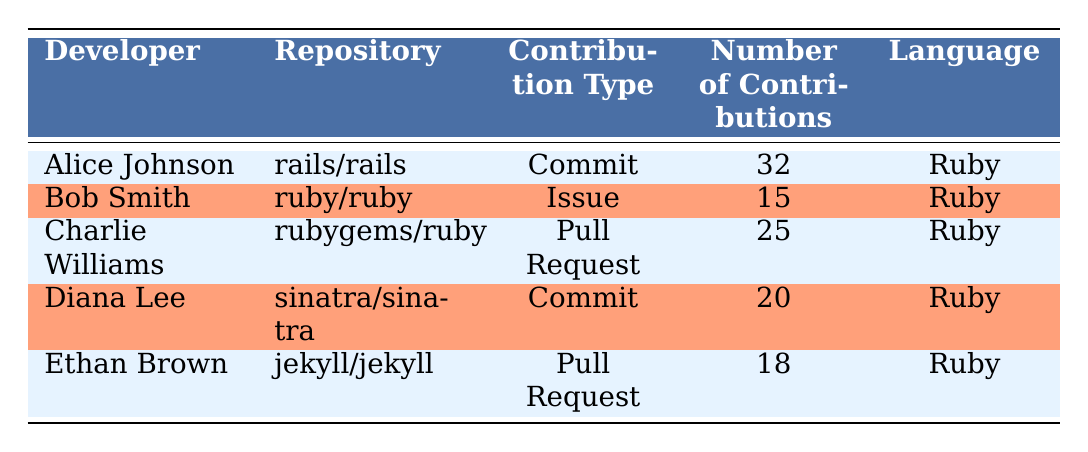What is the total number of contributions made by Alice Johnson? Alice Johnson made 32 contributions according to the table, which can be found in the "Number of Contributions" column corresponding to her name.
Answer: 32 Which developer contributed the most to the repository? Alice Johnson contributed the most with 32 contributions, which is the highest number listed in the "Number of Contributions" column.
Answer: Alice Johnson Is there a developer who only contributed by creating issues? Yes, Bob Smith is the only developer who contributed by creating issues, as indicated by his contribution type in the table.
Answer: Yes What is the average number of contributions from all developers listed? To find the average, first sum up the total contributions: 32 (Alice) + 15 (Bob) + 25 (Charlie) + 20 (Diana) + 18 (Ethan) = 110. Then divide by the number of developers, which is 5: 110 / 5 = 22.
Answer: 22 Did any developers have more than 20 contributions in total? Yes, Alice Johnson with 32 contributions and Charlie Williams with 25 contributions are the developers who had more than 20 contributions, as seen in the table.
Answer: Yes What is the total number of contributions from developers who worked on Pull Requests? The total contributions from developers who worked on Pull Requests are calculated by adding Charlie Williams' 25 and Ethan Brown's 18 contributions, resulting in 25 + 18 = 43.
Answer: 43 Which developer contributed to the "sinatra/sinatra" repository? Diana Lee contributed to the "sinatra/sinatra" repository, as indicated under the "Repository" column for her name.
Answer: Diana Lee Were there more Commit contributions than Pull Request contributions? Yes, when summing them up, there are 32 (Alice, Commit) + 20 (Diana, Commit) = 52 Commit contributions and 25 (Charlie, Pull Request) + 18 (Ethan, Pull Request) = 43 Pull Request contributions. So, Commit contributions (52) exceed Pull Request contributions (43).
Answer: Yes 